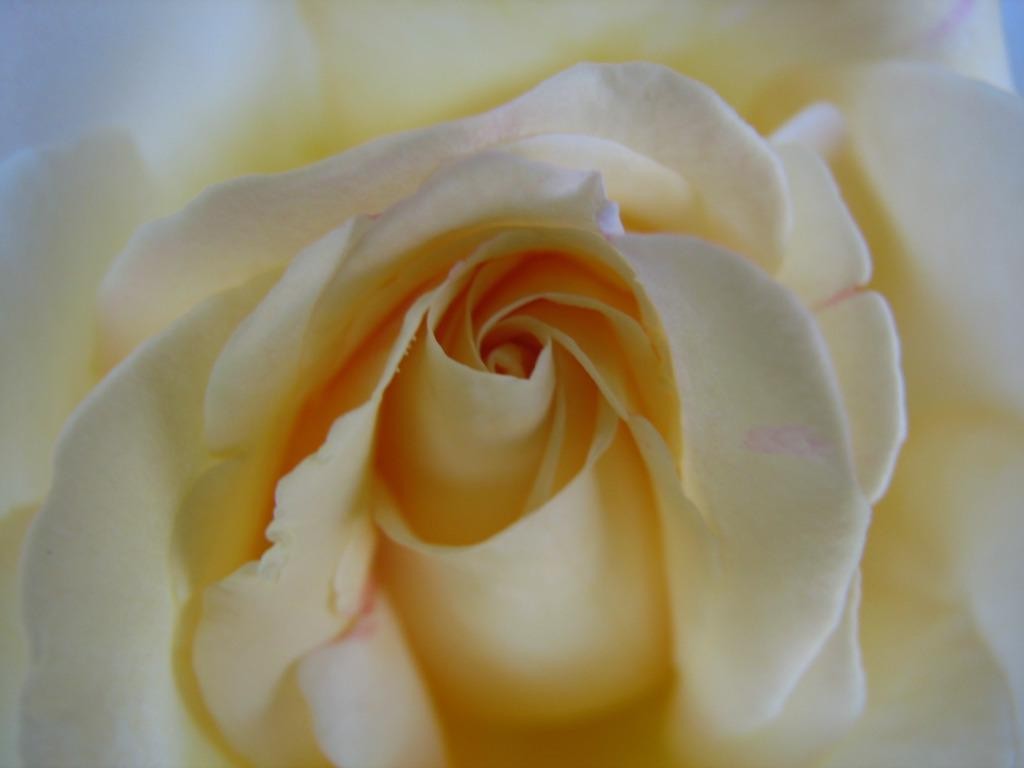What type of flower is present in the image? There is a yellow color rose in the image. Can you see any dogs playing on the seashore in the image? There is no seashore or dogs present in the image; it features a yellow color rose. Is the rose stored in a jar in the image? The image does not show the rose being stored in a jar; it is simply a rose by itself. 